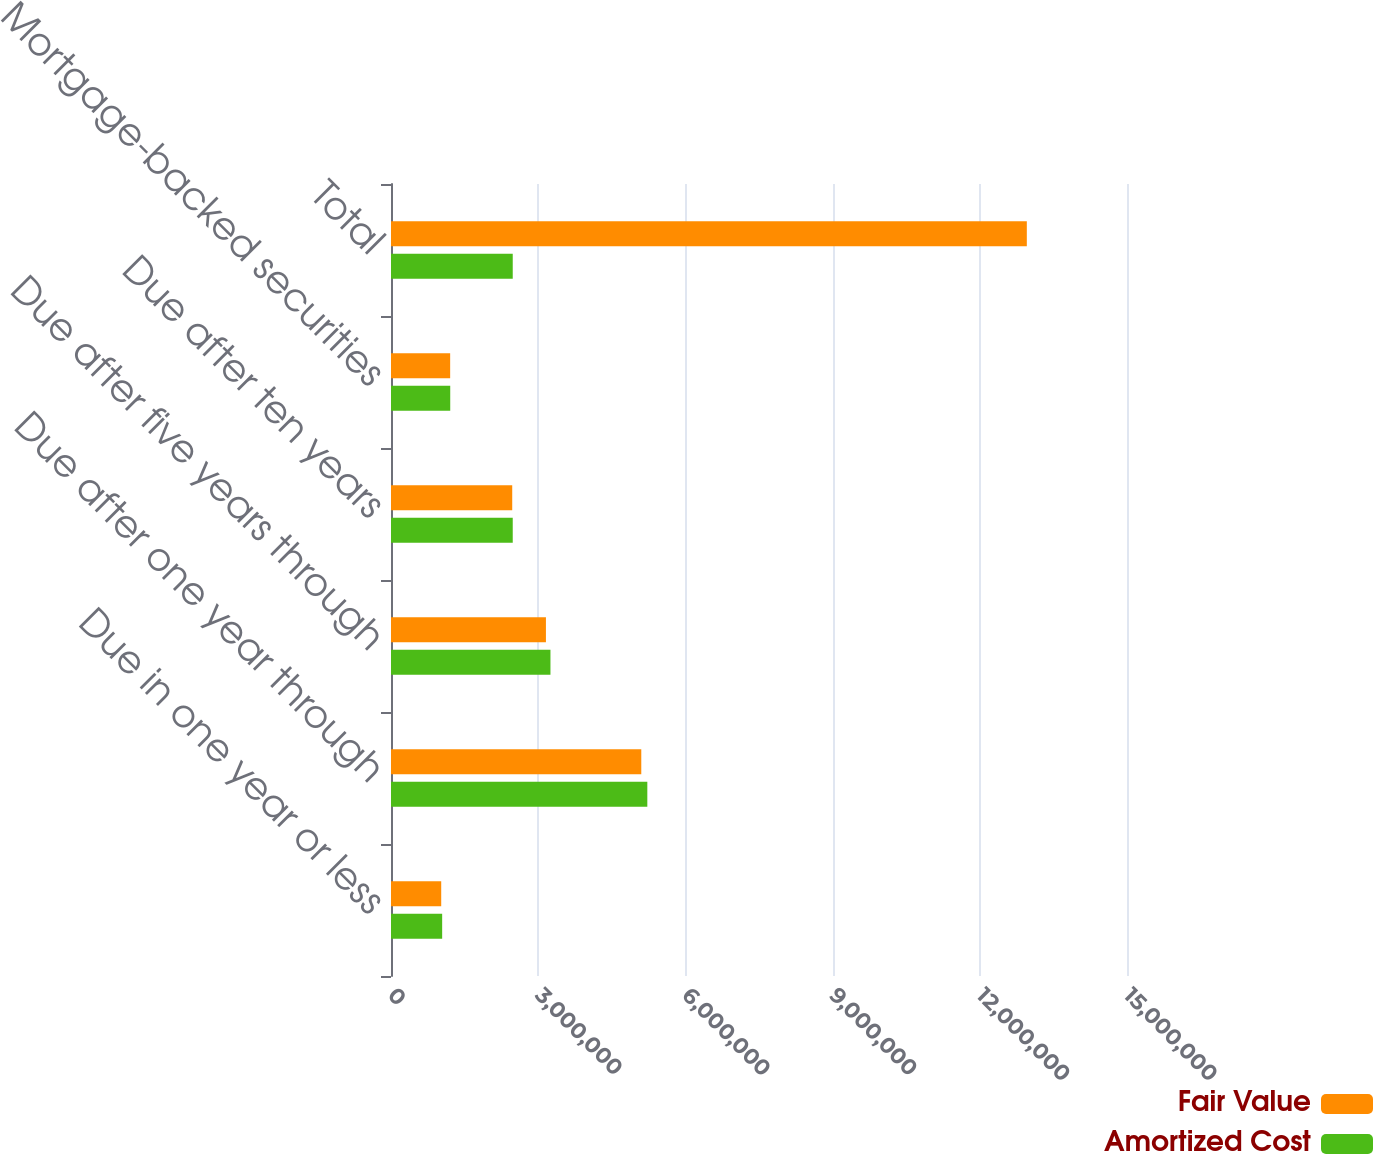Convert chart. <chart><loc_0><loc_0><loc_500><loc_500><stacked_bar_chart><ecel><fcel>Due in one year or less<fcel>Due after one year through<fcel>Due after five years through<fcel>Due after ten years<fcel>Mortgage-backed securities<fcel>Total<nl><fcel>Fair Value<fcel>1.02341e+06<fcel>5.10088e+06<fcel>3.15758e+06<fcel>2.47068e+06<fcel>1.20578e+06<fcel>1.29583e+07<nl><fcel>Amortized Cost<fcel>1.04271e+06<fcel>5.22394e+06<fcel>3.24973e+06<fcel>2.48115e+06<fcel>1.20728e+06<fcel>2.48115e+06<nl></chart> 